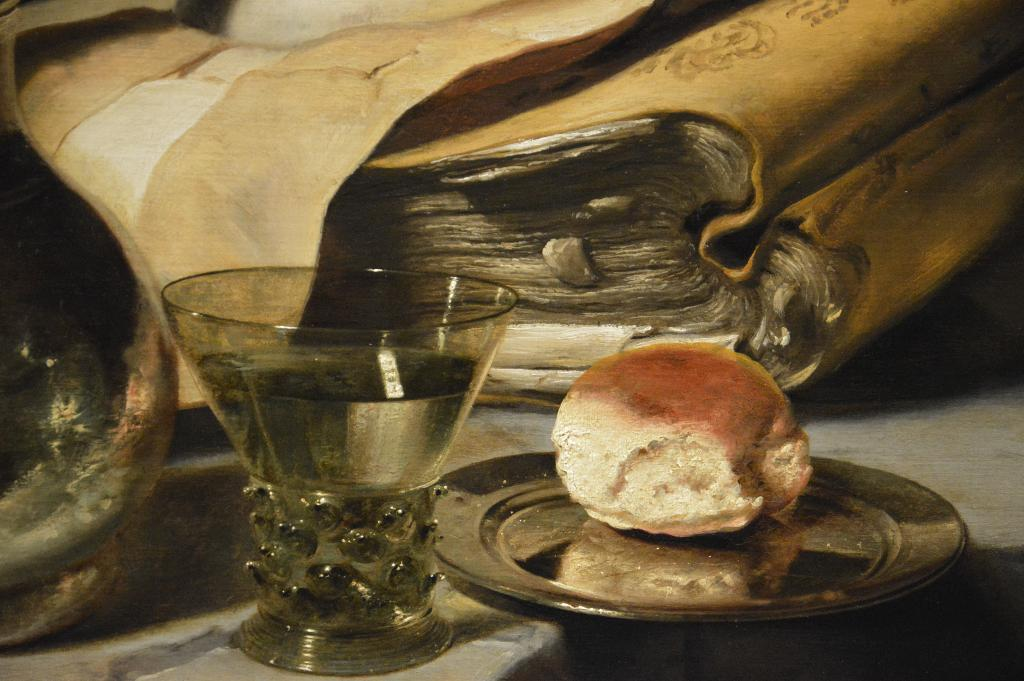What type of container is visible in the image? There is a glass in the image. What type of food item can be seen on a plate in the image? There is a plate with bread in the image. What type of object is present in the image that is typically used for reading? There is a book in the image. Can you describe the object on the left side of the image? Unfortunately, the facts provided do not give enough information to describe the object on the left side of the image. How many houses are visible in the image? There are no houses visible in the image. What type of cave can be seen in the image? There is no cave present in the image. 